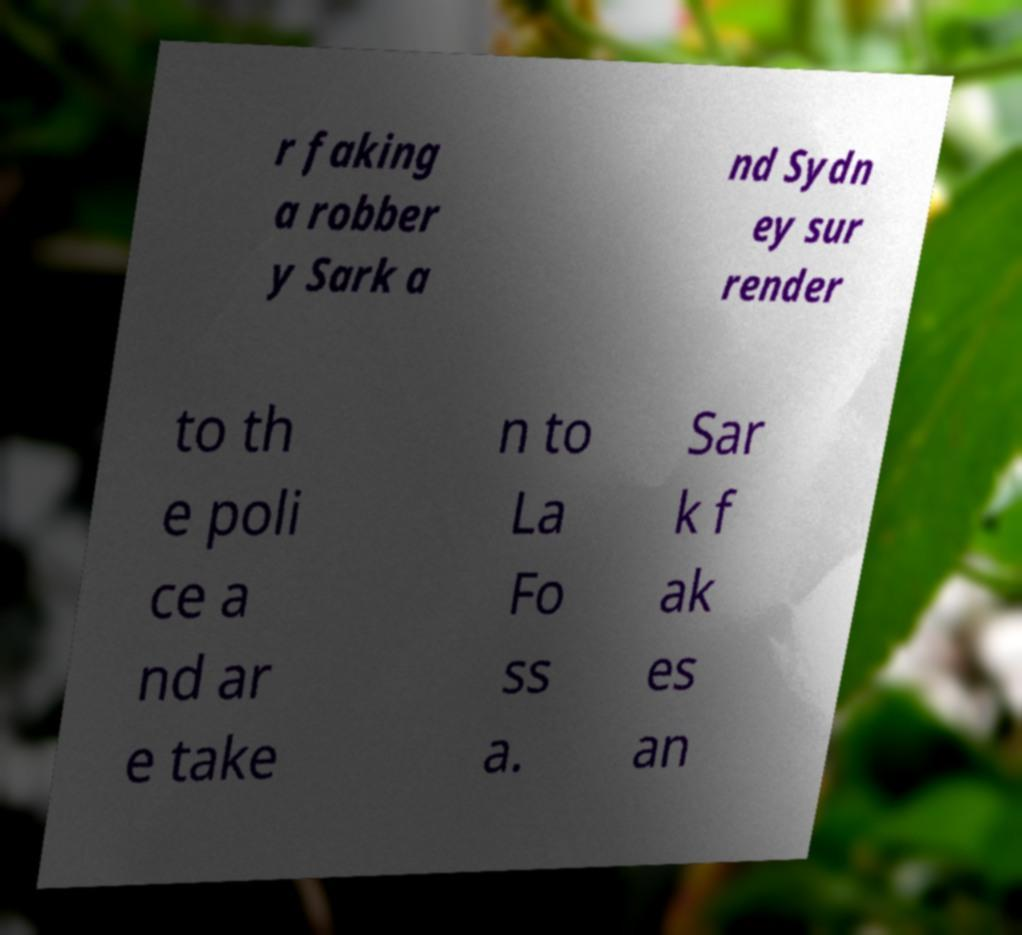What messages or text are displayed in this image? I need them in a readable, typed format. r faking a robber y Sark a nd Sydn ey sur render to th e poli ce a nd ar e take n to La Fo ss a. Sar k f ak es an 